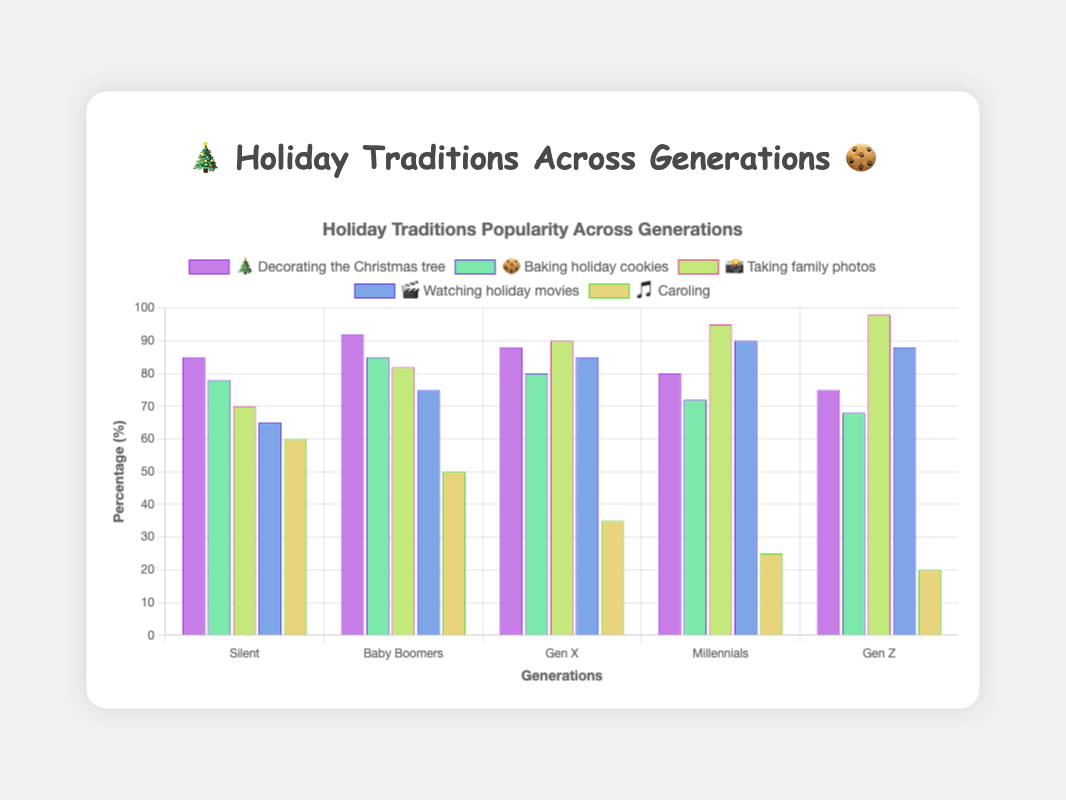What's the percentage of Baby Boomers who enjoy baking holiday cookies? According to the figure, the Baby Boomers' data bar for baking holiday cookies is highlighted with an 85% mark.
Answer: 85% Which generation enjoys caroling the most? By observing the height of the bars for the "🎵 Caroling" tradition across generations, the Silent generation has the tallest bar (60%).
Answer: Silent What is the average percentage of Millennials participating in all listed traditions? The percentages for the traditions relevant to Millennials are: 80% (tree), 72% (cookies), 95% (photos), 90% (movies), and 25% (caroling). Summing them: 80 + 72 + 95 + 90 + 25 = 362. Dividing by 5 gives the average: 362 / 5 = 72.4%.
Answer: 72.4% How much higher is the percentage of Gen X taking family photos compared to the Silent generation? Gen X (90%) - Silent (70%) = 20%.
Answer: 20% Which generation is least interested in decorating the Christmas tree? Observing the bar heights for "🎄 Tree," Generation Z has the lowest bar at 75%.
Answer: Gen Z Is participating in watching holiday movies more popular among Millennials or Gen Z? Comparing the bar heights for "🎬 Movies": Millennials (90%) vs. Gen Z (88%). Millennials is higher.
Answer: Millennials What’s the difference in participation percentage between Baby Boomers and Gen Z for baking holiday cookies? Baby Boomers (85%) - Gen Z (68%) = 17%.
Answer: 17% 